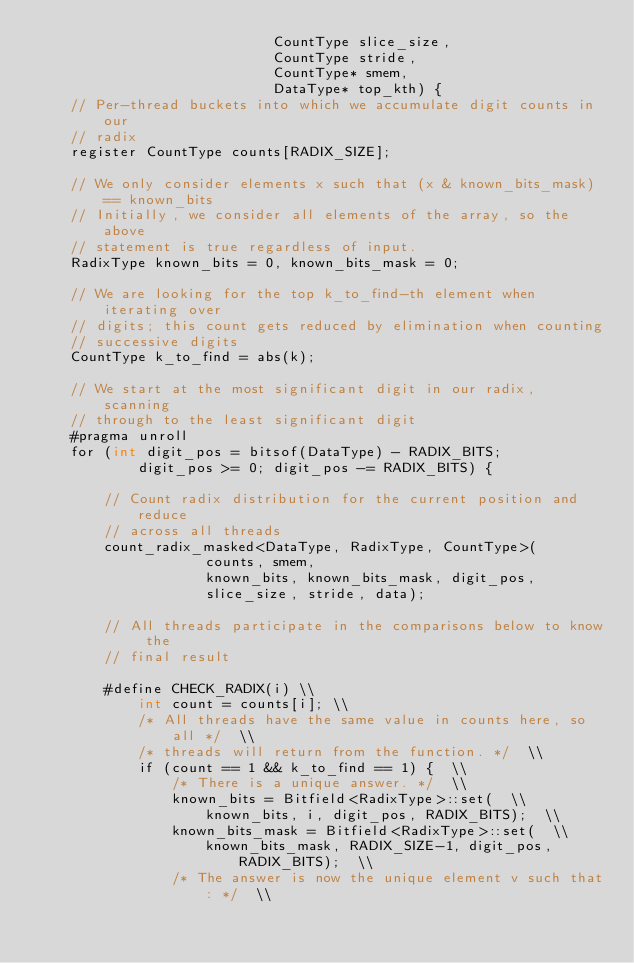Convert code to text. <code><loc_0><loc_0><loc_500><loc_500><_Cuda_>                            CountType slice_size,
                            CountType stride,
                            CountType* smem,
                            DataType* top_kth) {
    // Per-thread buckets into which we accumulate digit counts in our
    // radix
    register CountType counts[RADIX_SIZE];

    // We only consider elements x such that (x & known_bits_mask) == known_bits
    // Initially, we consider all elements of the array, so the above
    // statement is true regardless of input.
    RadixType known_bits = 0, known_bits_mask = 0;

    // We are looking for the top k_to_find-th element when iterating over
    // digits; this count gets reduced by elimination when counting
    // successive digits
    CountType k_to_find = abs(k);

    // We start at the most significant digit in our radix, scanning
    // through to the least significant digit
    #pragma unroll
    for (int digit_pos = bitsof(DataType) - RADIX_BITS;
            digit_pos >= 0; digit_pos -= RADIX_BITS) {

        // Count radix distribution for the current position and reduce
        // across all threads
        count_radix_masked<DataType, RadixType, CountType>(
                    counts, smem,
                    known_bits, known_bits_mask, digit_pos,
                    slice_size, stride, data);

        // All threads participate in the comparisons below to know the
        // final result

        #define CHECK_RADIX(i) \\
            int count = counts[i]; \\
            /* All threads have the same value in counts here, so all */  \\
            /* threads will return from the function. */  \\
            if (count == 1 && k_to_find == 1) {  \\
                /* There is a unique answer. */  \\
                known_bits = Bitfield<RadixType>::set(  \\
                    known_bits, i, digit_pos, RADIX_BITS);  \\
                known_bits_mask = Bitfield<RadixType>::set(  \\
                    known_bits_mask, RADIX_SIZE-1, digit_pos, RADIX_BITS);  \\
                /* The answer is now the unique element v such that: */  \\</code> 